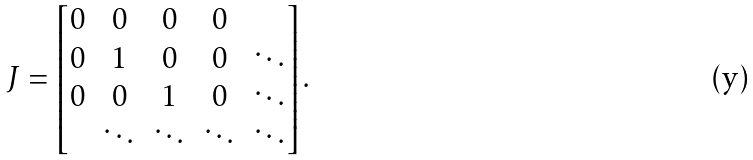<formula> <loc_0><loc_0><loc_500><loc_500>J = \left [ \begin{matrix} 0 & 0 & 0 & 0 & \\ 0 & 1 & 0 & 0 & \ddots \\ 0 & 0 & 1 & 0 & \ddots \\ & \ddots & \ddots & \ddots & \ddots \\ \end{matrix} \right ] .</formula> 